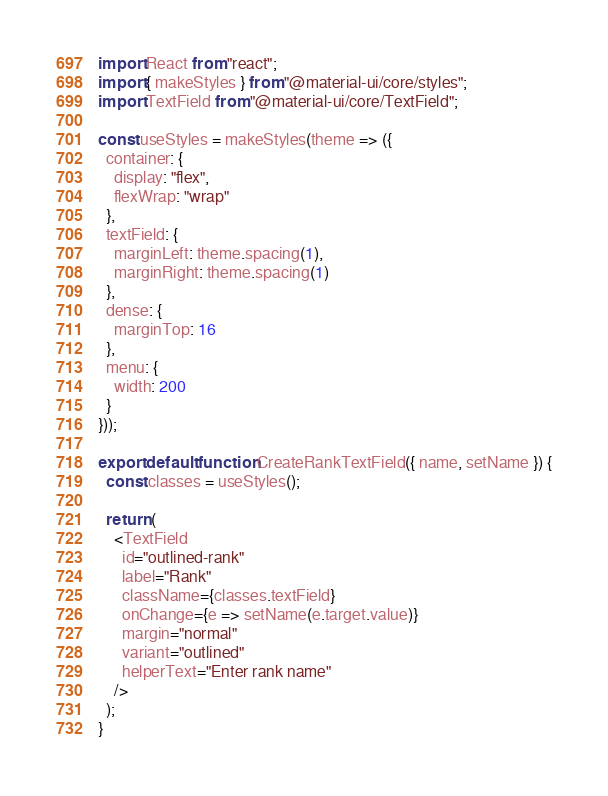<code> <loc_0><loc_0><loc_500><loc_500><_JavaScript_>import React from "react";
import { makeStyles } from "@material-ui/core/styles";
import TextField from "@material-ui/core/TextField";

const useStyles = makeStyles(theme => ({
  container: {
    display: "flex",
    flexWrap: "wrap"
  },
  textField: {
    marginLeft: theme.spacing(1),
    marginRight: theme.spacing(1)
  },
  dense: {
    marginTop: 16
  },
  menu: {
    width: 200
  }
}));

export default function CreateRankTextField({ name, setName }) {
  const classes = useStyles();

  return (
    <TextField
      id="outlined-rank"
      label="Rank"
      className={classes.textField}
      onChange={e => setName(e.target.value)}
      margin="normal"
      variant="outlined"
      helperText="Enter rank name"
    />
  );
}
</code> 